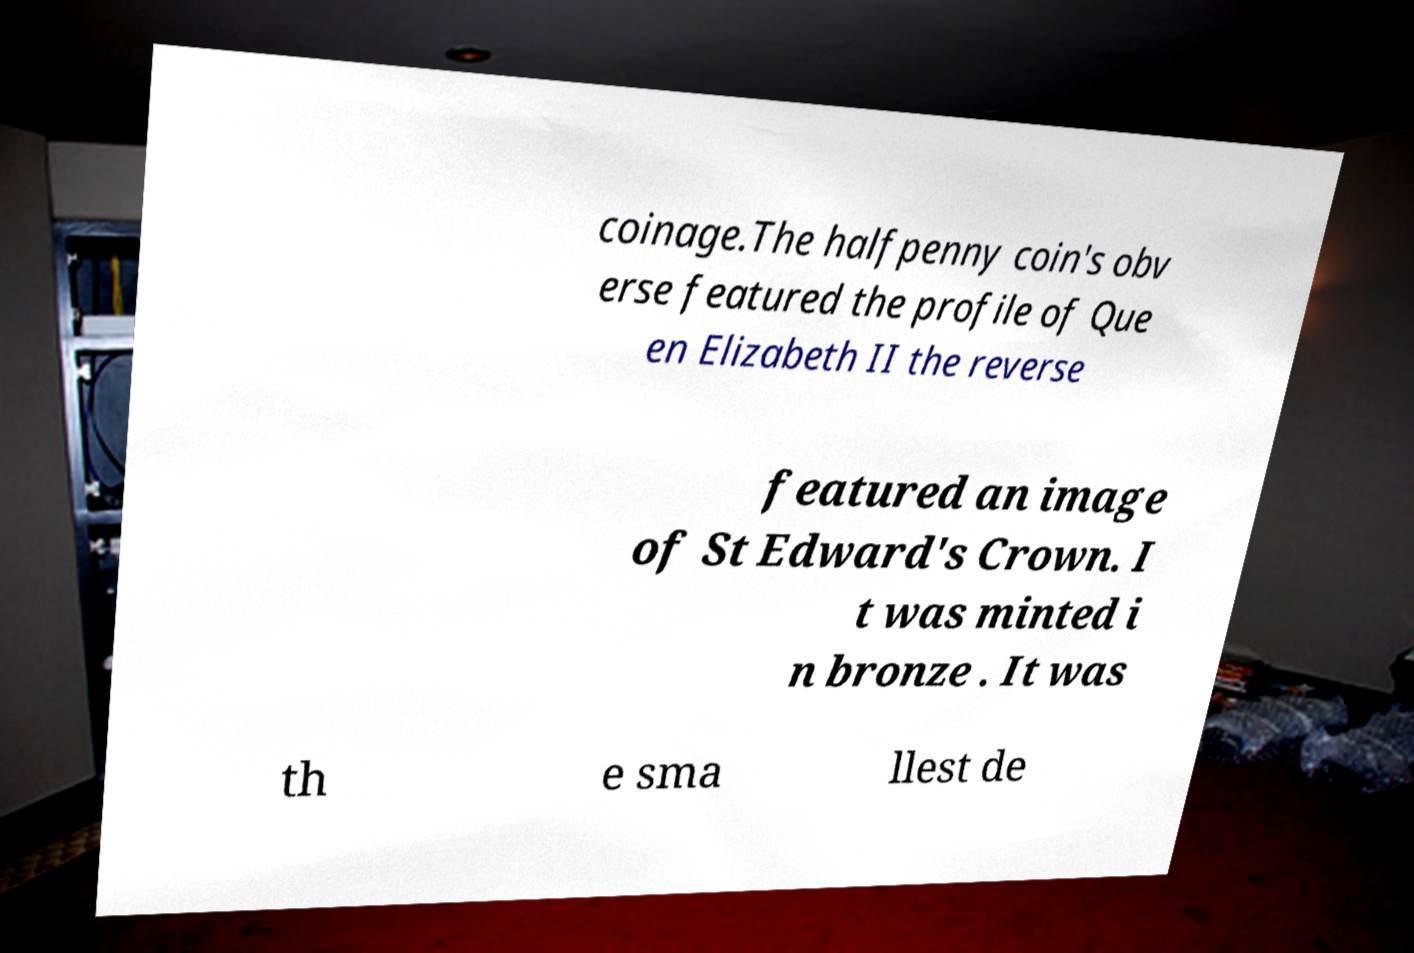Could you extract and type out the text from this image? coinage.The halfpenny coin's obv erse featured the profile of Que en Elizabeth II the reverse featured an image of St Edward's Crown. I t was minted i n bronze . It was th e sma llest de 